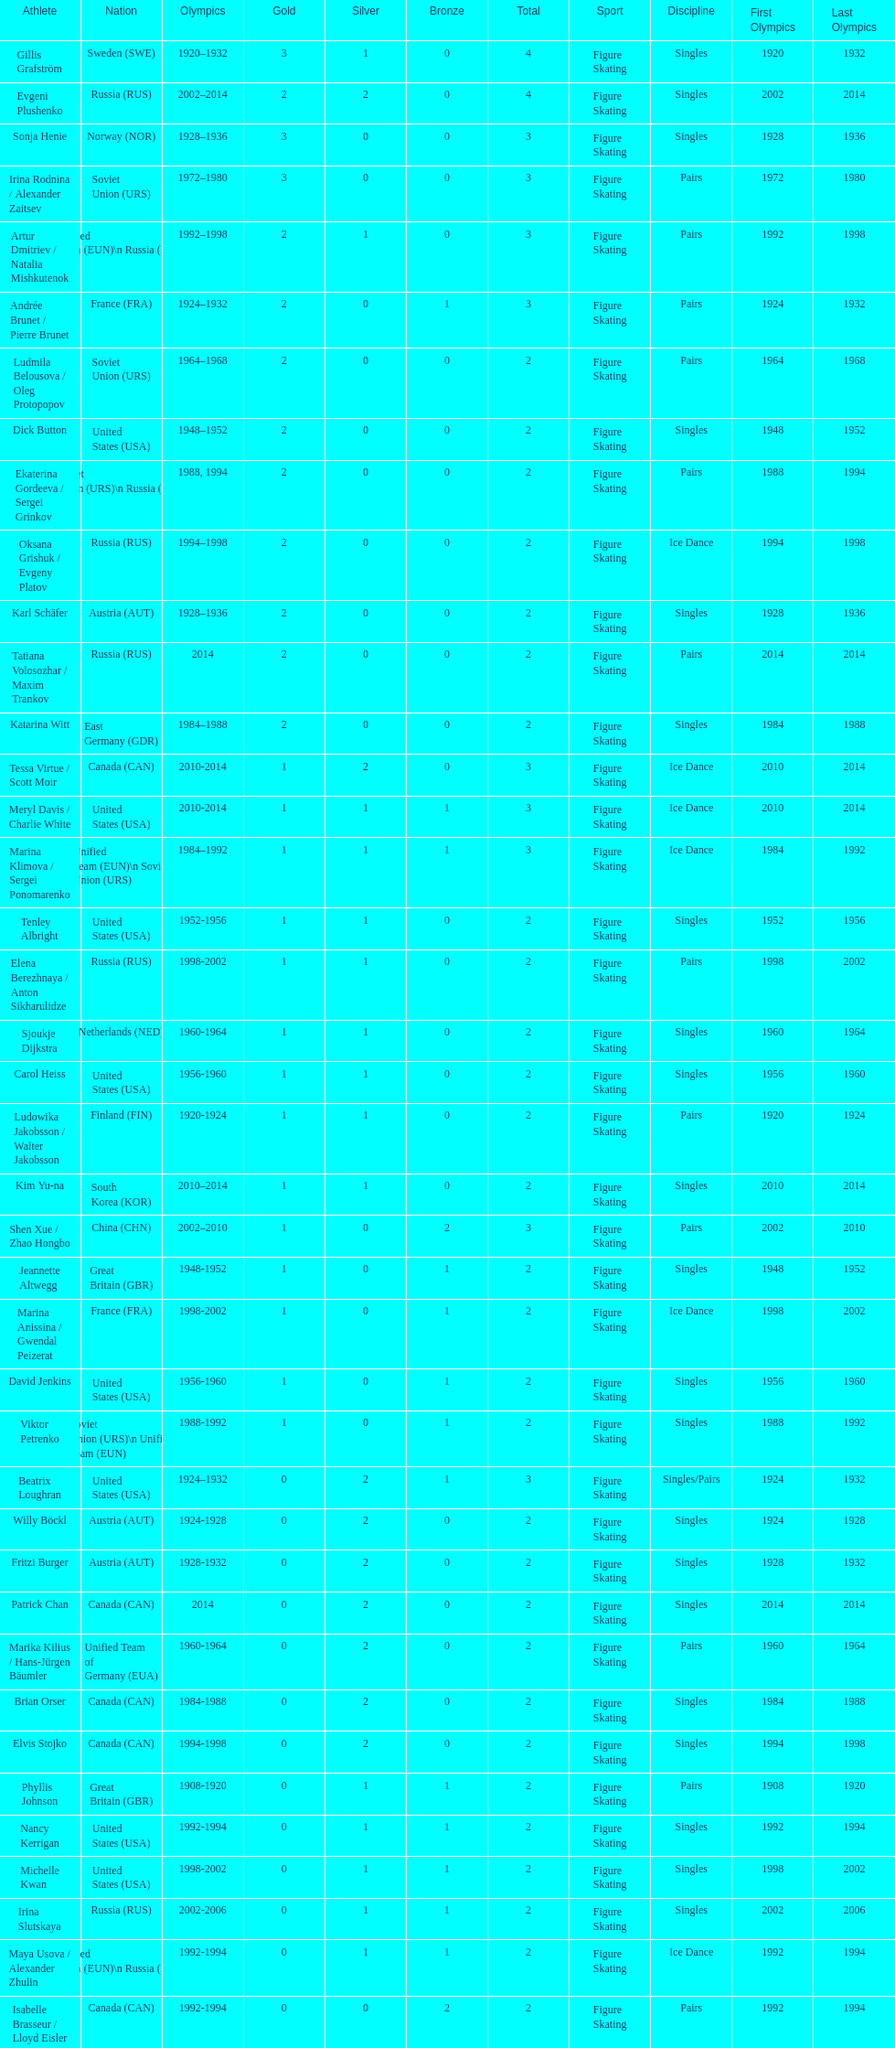How many more silver medals did gillis grafström have compared to sonja henie? 1. 